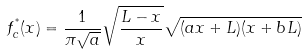<formula> <loc_0><loc_0><loc_500><loc_500>f _ { c } ^ { ^ { * } } ( x ) = \frac { 1 } { \pi \sqrt { a } } \sqrt { \frac { L - x } { x } } \sqrt { ( a x + L ) ( x + b L ) }</formula> 